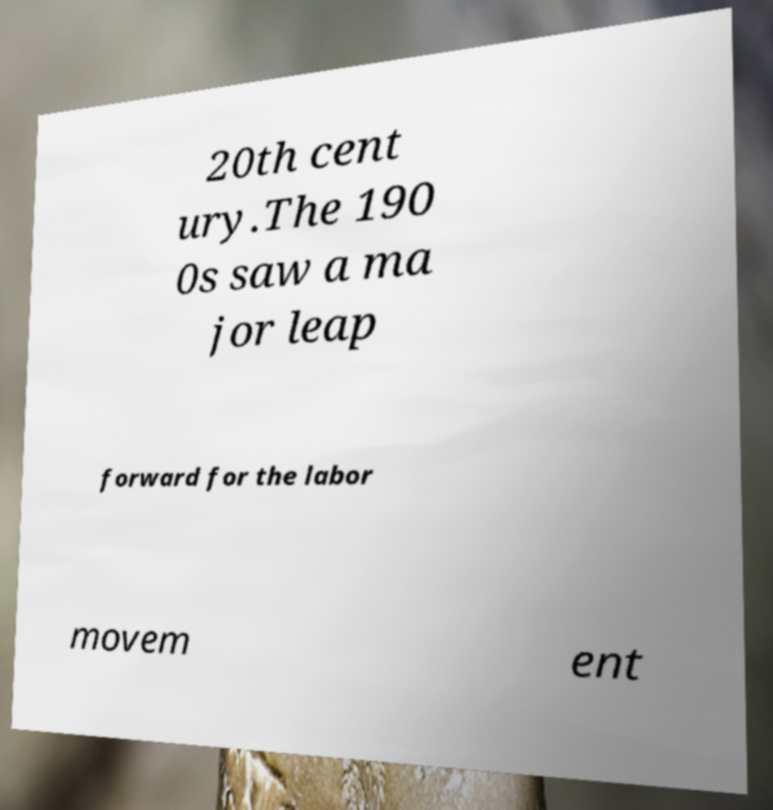Could you extract and type out the text from this image? 20th cent ury.The 190 0s saw a ma jor leap forward for the labor movem ent 